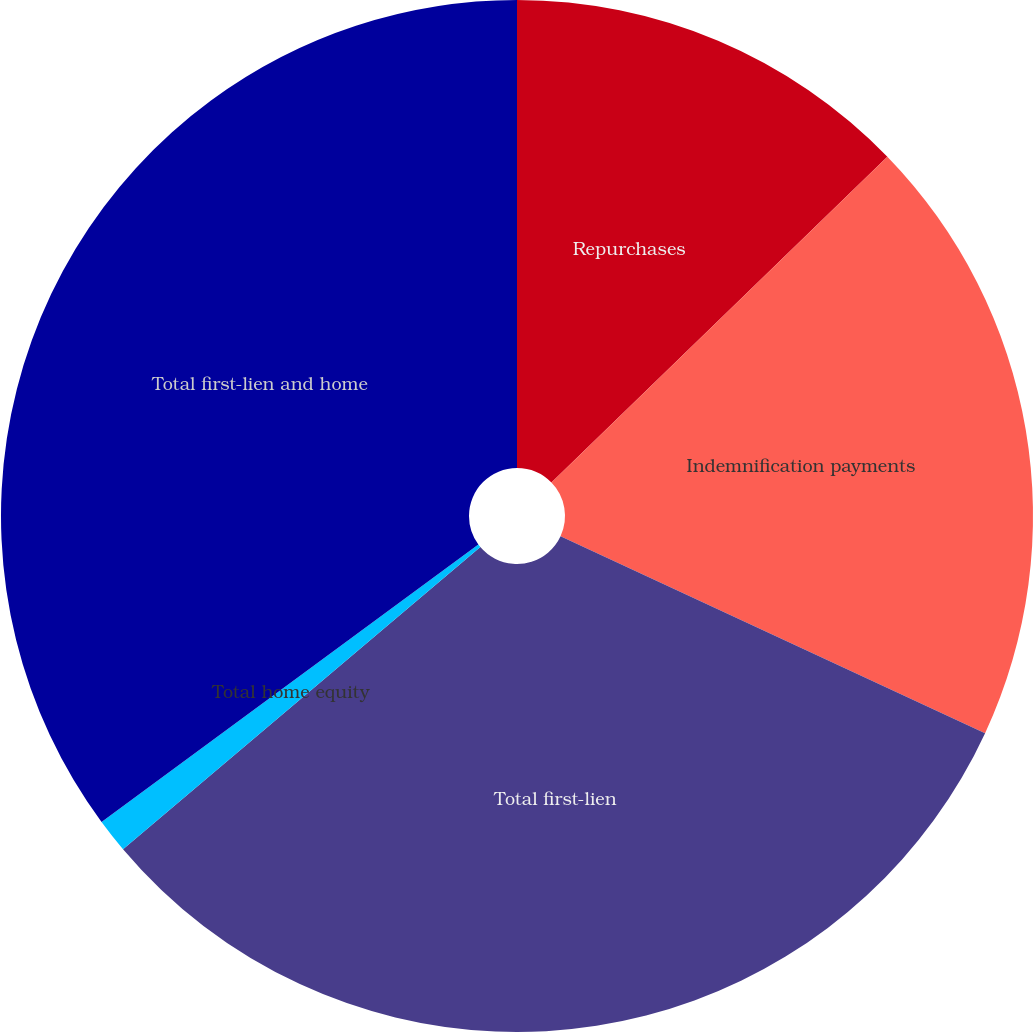<chart> <loc_0><loc_0><loc_500><loc_500><pie_chart><fcel>Repurchases<fcel>Indemnification payments<fcel>Total first-lien<fcel>Total home equity<fcel>Total first-lien and home<nl><fcel>12.74%<fcel>19.17%<fcel>31.91%<fcel>1.07%<fcel>35.1%<nl></chart> 